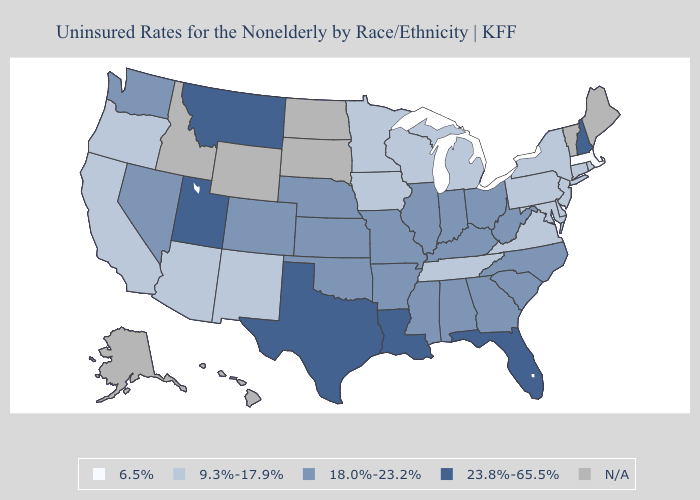Name the states that have a value in the range 18.0%-23.2%?
Write a very short answer. Alabama, Arkansas, Colorado, Georgia, Illinois, Indiana, Kansas, Kentucky, Mississippi, Missouri, Nebraska, Nevada, North Carolina, Ohio, Oklahoma, South Carolina, Washington, West Virginia. Among the states that border Minnesota , which have the lowest value?
Short answer required. Iowa, Wisconsin. What is the highest value in states that border New Jersey?
Concise answer only. 9.3%-17.9%. What is the value of North Carolina?
Answer briefly. 18.0%-23.2%. What is the value of Ohio?
Short answer required. 18.0%-23.2%. Name the states that have a value in the range N/A?
Short answer required. Alaska, Hawaii, Idaho, Maine, North Dakota, South Dakota, Vermont, Wyoming. Does the first symbol in the legend represent the smallest category?
Write a very short answer. Yes. What is the lowest value in the MidWest?
Short answer required. 9.3%-17.9%. What is the value of Vermont?
Short answer required. N/A. What is the value of Delaware?
Write a very short answer. 9.3%-17.9%. What is the value of West Virginia?
Keep it brief. 18.0%-23.2%. What is the value of Idaho?
Answer briefly. N/A. What is the value of Iowa?
Answer briefly. 9.3%-17.9%. 